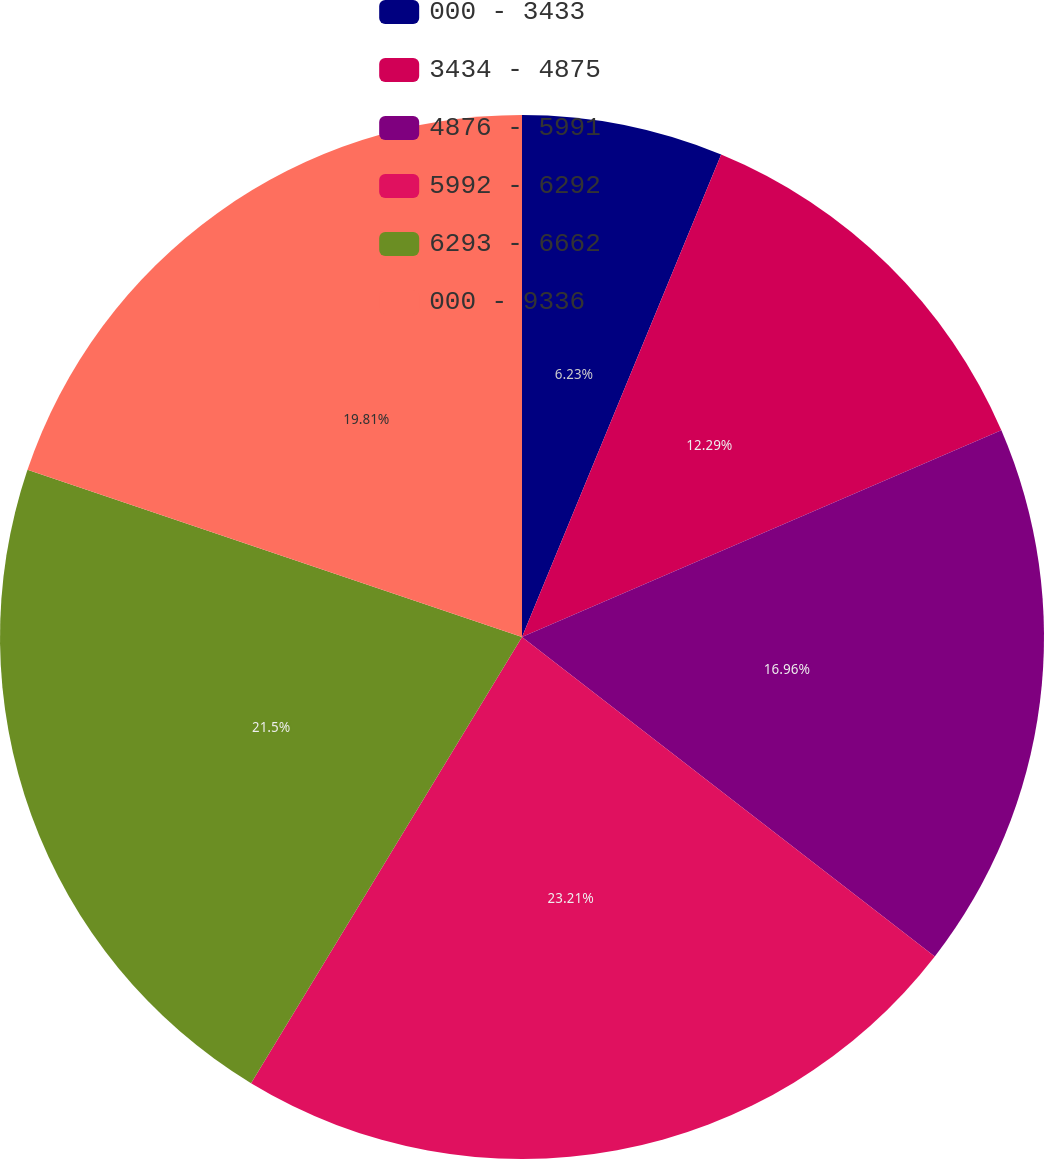Convert chart to OTSL. <chart><loc_0><loc_0><loc_500><loc_500><pie_chart><fcel>000 - 3433<fcel>3434 - 4875<fcel>4876 - 5991<fcel>5992 - 6292<fcel>6293 - 6662<fcel>000 - 9336<nl><fcel>6.23%<fcel>12.29%<fcel>16.96%<fcel>23.2%<fcel>21.5%<fcel>19.81%<nl></chart> 